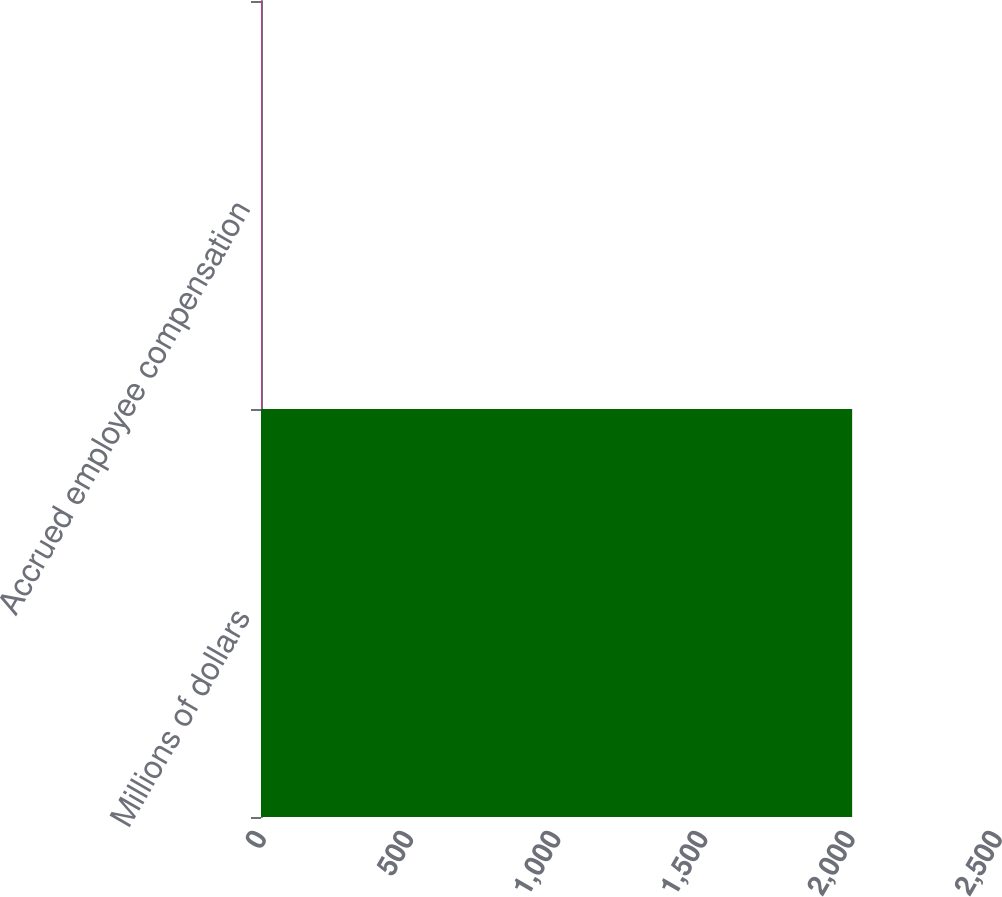Convert chart. <chart><loc_0><loc_0><loc_500><loc_500><bar_chart><fcel>Millions of dollars<fcel>Accrued employee compensation<nl><fcel>2008<fcel>2<nl></chart> 